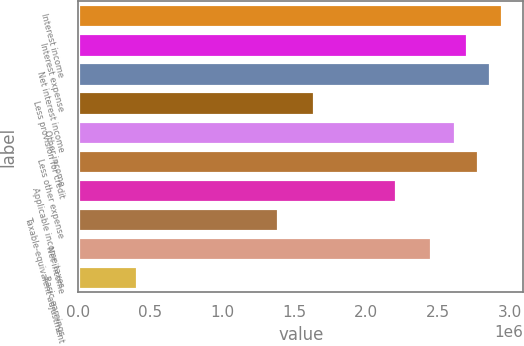Convert chart to OTSL. <chart><loc_0><loc_0><loc_500><loc_500><bar_chart><fcel>Interest income<fcel>Interest expense<fcel>Net interest income<fcel>Less provision for credit<fcel>Other income<fcel>Less other expense<fcel>Applicable income taxes<fcel>Taxable-equivalent adjustment<fcel>Net income<fcel>Basic earnings<nl><fcel>2.94319e+06<fcel>2.69792e+06<fcel>2.86143e+06<fcel>1.6351e+06<fcel>2.61617e+06<fcel>2.77968e+06<fcel>2.20739e+06<fcel>1.38984e+06<fcel>2.45266e+06<fcel>408776<nl></chart> 